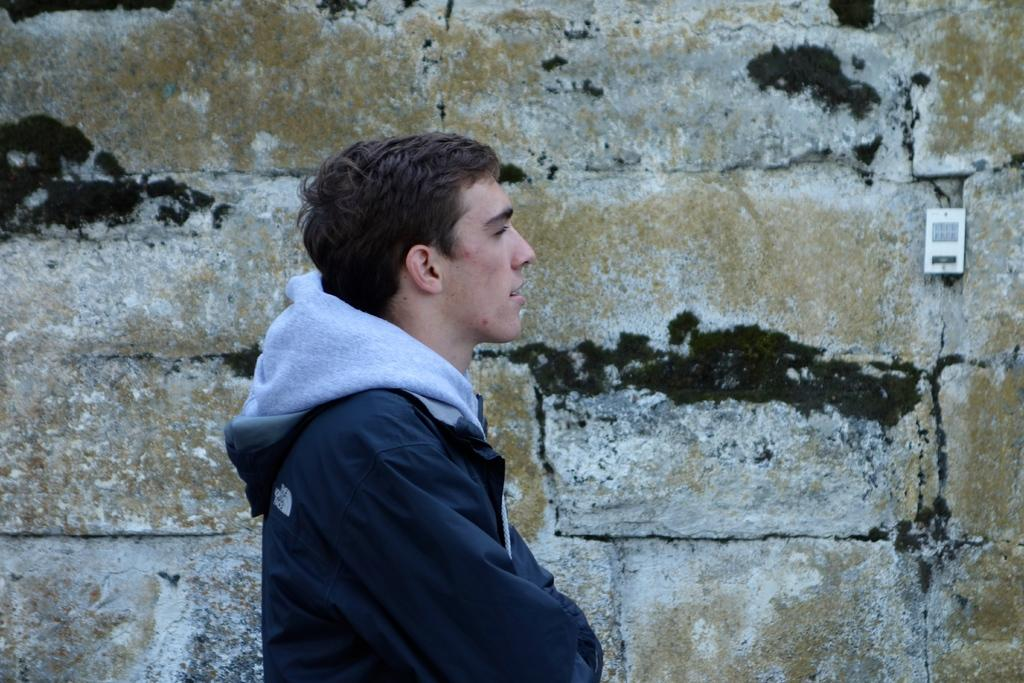What is present in the image? There is a man in the image. What can be seen in the background of the image? There is a wall in the background of the image. Can you describe the object in the background of the image? Unfortunately, the provided facts do not give enough information to describe the object in the background. What type of payment method is being used by the man in the image? There is no indication in the image that the man is using any payment method. What scientific theory is being discussed by the man in the image? There is no indication in the image that the man is discussing any scientific theory. 